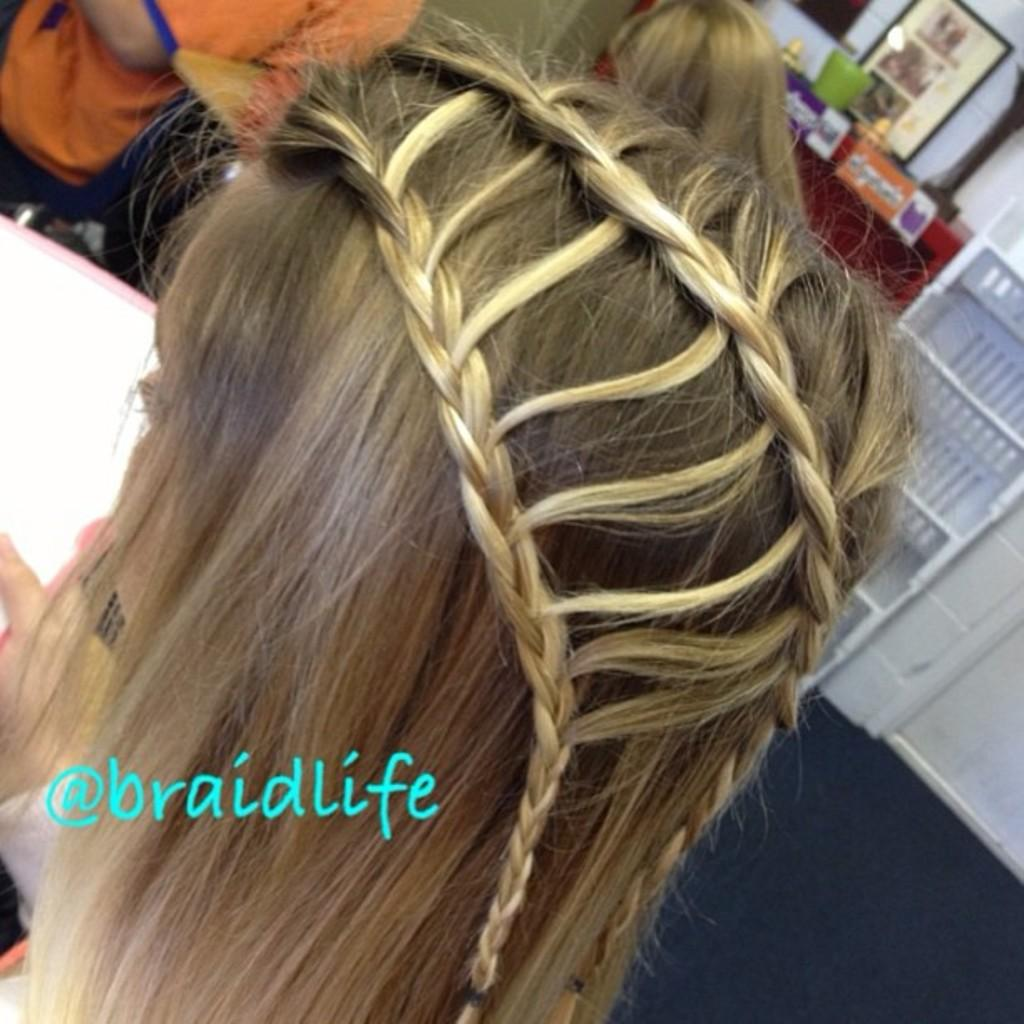What is the main subject of the image? There is a person's head in the image. Are there any other people visible in the image? Yes, there are people visible on the backside of the image. What can be seen on a surface in the image? There are objects placed on a surface in the image. What type of storage feature is present in the image? There are shelves in the image. What is hanging on a wall in the image? There is a photo frame on a wall in the image. How many mittens are hanging on the wall in the image? There are no mittens present in the image. What type of birds can be seen flying in the image? There are no birds visible in the image. 